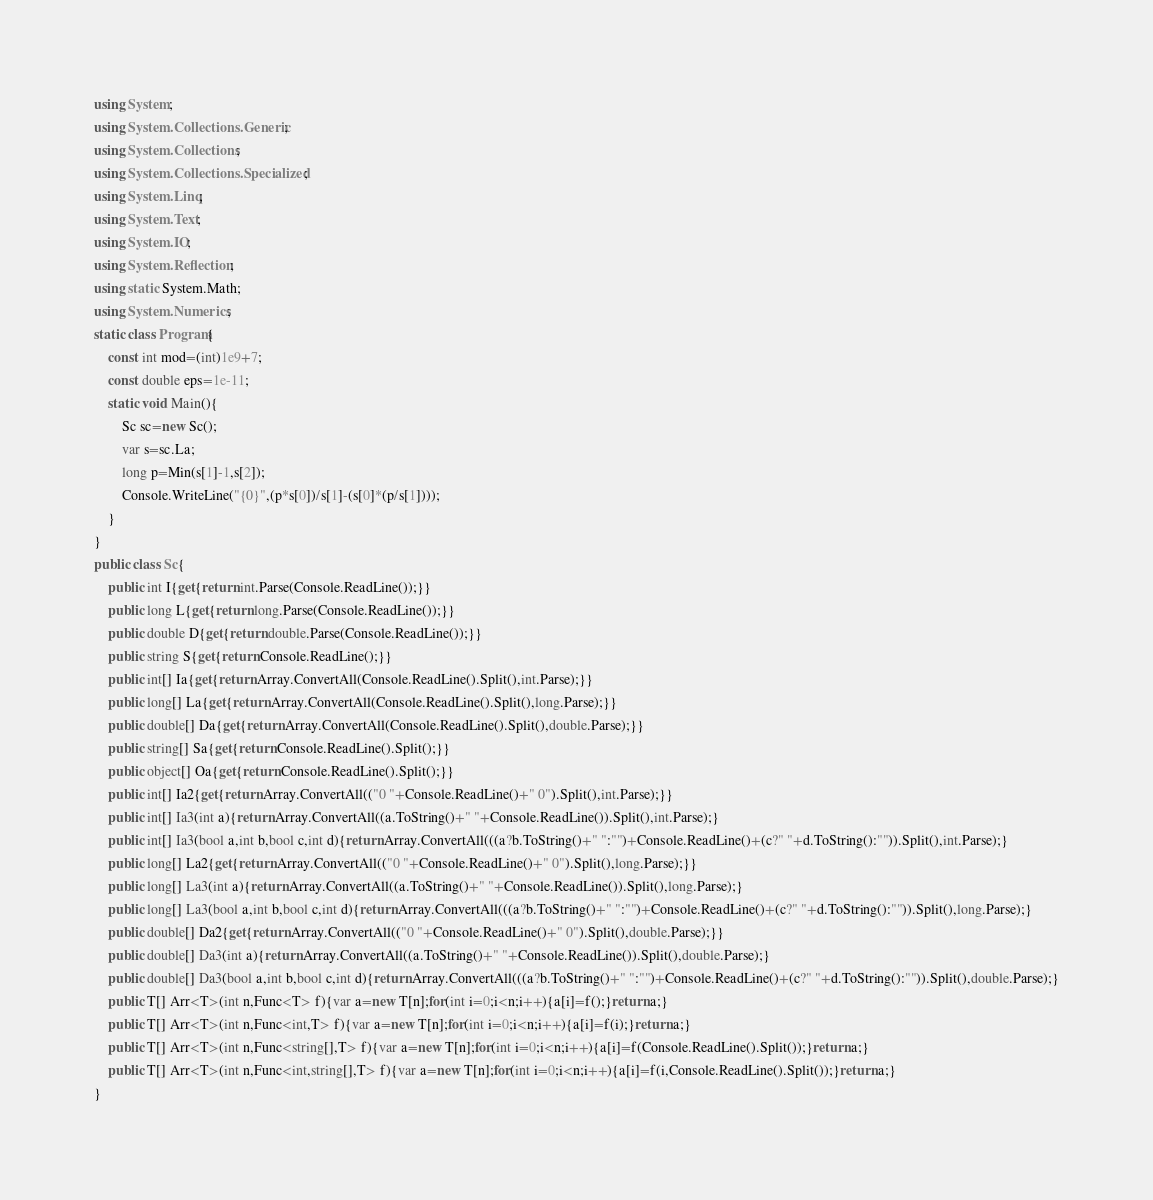Convert code to text. <code><loc_0><loc_0><loc_500><loc_500><_C#_>using System;
using System.Collections.Generic;
using System.Collections;
using System.Collections.Specialized;
using System.Linq;
using System.Text;
using System.IO;
using System.Reflection;
using static System.Math;
using System.Numerics;
static class Program{
	const int mod=(int)1e9+7;
	const double eps=1e-11;
	static void Main(){
		Sc sc=new Sc();
		var s=sc.La;
		long p=Min(s[1]-1,s[2]);
		Console.WriteLine("{0}",(p*s[0])/s[1]-(s[0]*(p/s[1])));
	}
}
public class Sc{
	public int I{get{return int.Parse(Console.ReadLine());}}
	public long L{get{return long.Parse(Console.ReadLine());}}
	public double D{get{return double.Parse(Console.ReadLine());}}
	public string S{get{return Console.ReadLine();}}
	public int[] Ia{get{return Array.ConvertAll(Console.ReadLine().Split(),int.Parse);}}
	public long[] La{get{return Array.ConvertAll(Console.ReadLine().Split(),long.Parse);}}
	public double[] Da{get{return Array.ConvertAll(Console.ReadLine().Split(),double.Parse);}}
	public string[] Sa{get{return Console.ReadLine().Split();}}
	public object[] Oa{get{return Console.ReadLine().Split();}}
	public int[] Ia2{get{return Array.ConvertAll(("0 "+Console.ReadLine()+" 0").Split(),int.Parse);}}
	public int[] Ia3(int a){return Array.ConvertAll((a.ToString()+" "+Console.ReadLine()).Split(),int.Parse);}
	public int[] Ia3(bool a,int b,bool c,int d){return Array.ConvertAll(((a?b.ToString()+" ":"")+Console.ReadLine()+(c?" "+d.ToString():"")).Split(),int.Parse);}
	public long[] La2{get{return Array.ConvertAll(("0 "+Console.ReadLine()+" 0").Split(),long.Parse);}}
	public long[] La3(int a){return Array.ConvertAll((a.ToString()+" "+Console.ReadLine()).Split(),long.Parse);}
	public long[] La3(bool a,int b,bool c,int d){return Array.ConvertAll(((a?b.ToString()+" ":"")+Console.ReadLine()+(c?" "+d.ToString():"")).Split(),long.Parse);}
	public double[] Da2{get{return Array.ConvertAll(("0 "+Console.ReadLine()+" 0").Split(),double.Parse);}}
	public double[] Da3(int a){return Array.ConvertAll((a.ToString()+" "+Console.ReadLine()).Split(),double.Parse);}
	public double[] Da3(bool a,int b,bool c,int d){return Array.ConvertAll(((a?b.ToString()+" ":"")+Console.ReadLine()+(c?" "+d.ToString():"")).Split(),double.Parse);}
	public T[] Arr<T>(int n,Func<T> f){var a=new T[n];for(int i=0;i<n;i++){a[i]=f();}return a;}
	public T[] Arr<T>(int n,Func<int,T> f){var a=new T[n];for(int i=0;i<n;i++){a[i]=f(i);}return a;}
	public T[] Arr<T>(int n,Func<string[],T> f){var a=new T[n];for(int i=0;i<n;i++){a[i]=f(Console.ReadLine().Split());}return a;}
	public T[] Arr<T>(int n,Func<int,string[],T> f){var a=new T[n];for(int i=0;i<n;i++){a[i]=f(i,Console.ReadLine().Split());}return a;}
}</code> 